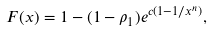Convert formula to latex. <formula><loc_0><loc_0><loc_500><loc_500>F ( x ) = 1 - ( 1 - \rho _ { 1 } ) e ^ { c ( 1 - 1 / x ^ { n } ) } ,</formula> 